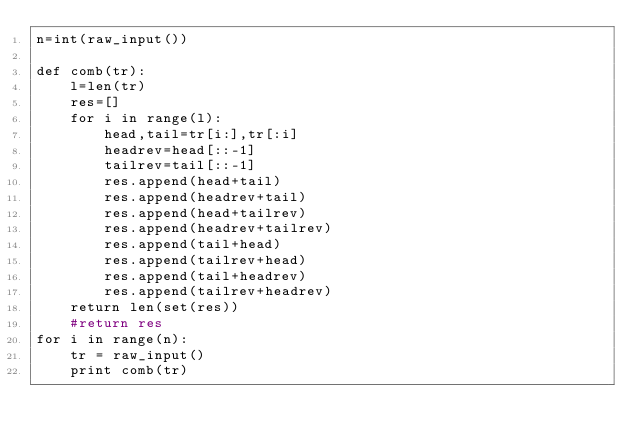<code> <loc_0><loc_0><loc_500><loc_500><_Python_>n=int(raw_input())

def comb(tr):
    l=len(tr)
    res=[]
    for i in range(l):
        head,tail=tr[i:],tr[:i]
        headrev=head[::-1]
        tailrev=tail[::-1]
        res.append(head+tail)
        res.append(headrev+tail)
        res.append(head+tailrev)
        res.append(headrev+tailrev)
        res.append(tail+head)
        res.append(tailrev+head)
        res.append(tail+headrev)
        res.append(tailrev+headrev)
    return len(set(res))
    #return res
for i in range(n):
    tr = raw_input()
    print comb(tr)</code> 